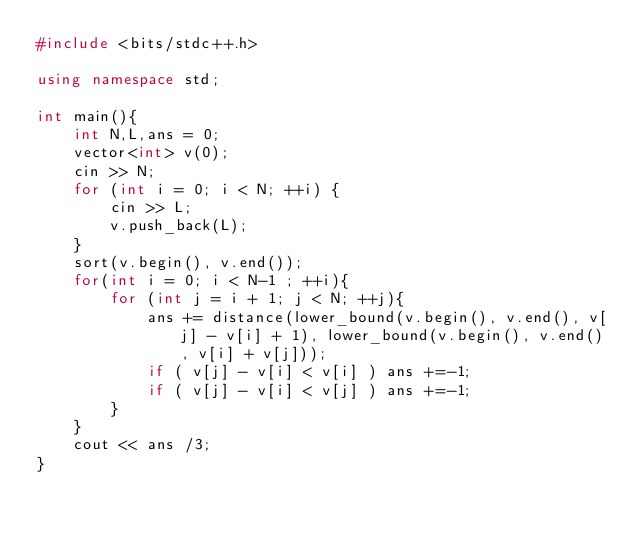<code> <loc_0><loc_0><loc_500><loc_500><_C++_>#include <bits/stdc++.h>

using namespace std;

int main(){
    int N,L,ans = 0;
    vector<int> v(0);
    cin >> N;
    for (int i = 0; i < N; ++i) {
        cin >> L;
        v.push_back(L);
    }
    sort(v.begin(), v.end());
    for(int i = 0; i < N-1 ; ++i){
        for (int j = i + 1; j < N; ++j){
            ans += distance(lower_bound(v.begin(), v.end(), v[j] - v[i] + 1), lower_bound(v.begin(), v.end(), v[i] + v[j]));
            if ( v[j] - v[i] < v[i] ) ans +=-1;
            if ( v[j] - v[i] < v[j] ) ans +=-1;
        }
    }
    cout << ans /3;
}


</code> 